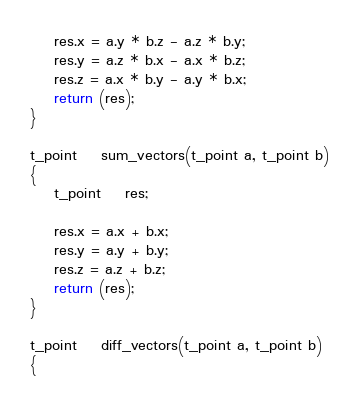Convert code to text. <code><loc_0><loc_0><loc_500><loc_500><_C_>	res.x = a.y * b.z - a.z * b.y;
	res.y = a.z * b.x - a.x * b.z;
	res.z = a.x * b.y - a.y * b.x;
	return (res);
}

t_point	sum_vectors(t_point a, t_point b)
{
	t_point	res;

	res.x = a.x + b.x;
	res.y = a.y + b.y;
	res.z = a.z + b.z;
	return (res);
}

t_point	diff_vectors(t_point a, t_point b)
{</code> 